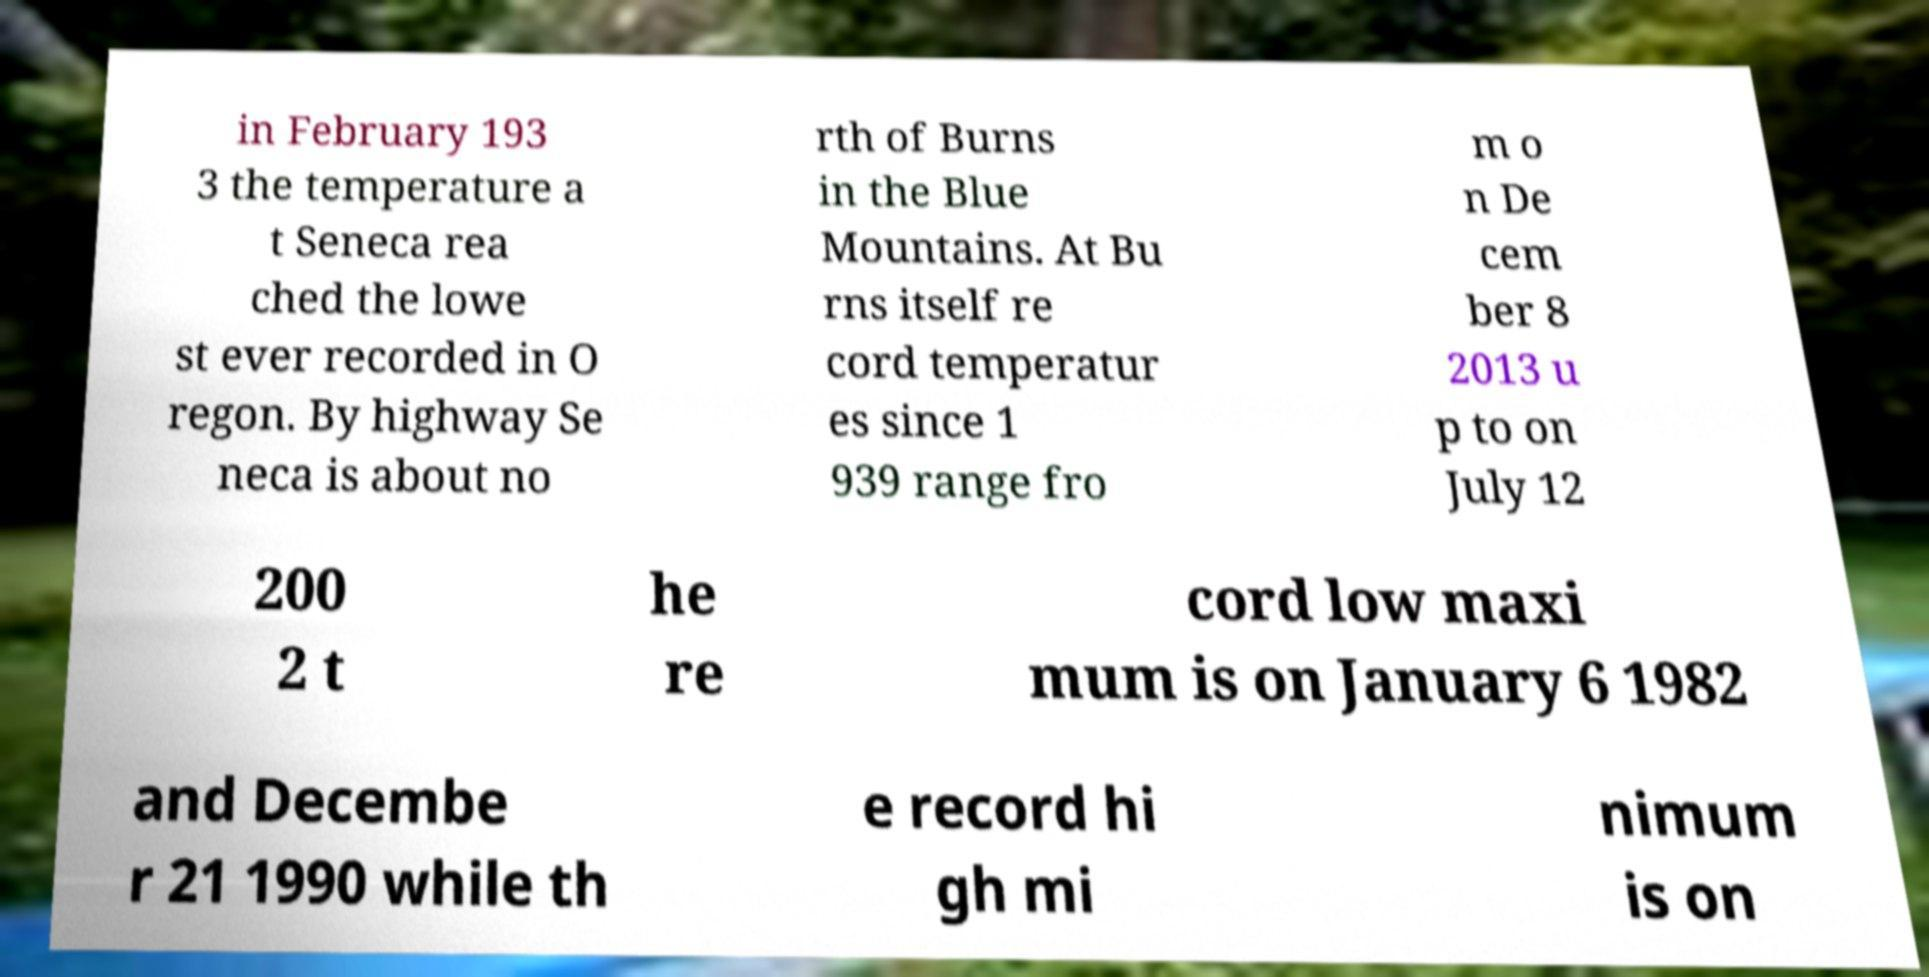I need the written content from this picture converted into text. Can you do that? in February 193 3 the temperature a t Seneca rea ched the lowe st ever recorded in O regon. By highway Se neca is about no rth of Burns in the Blue Mountains. At Bu rns itself re cord temperatur es since 1 939 range fro m o n De cem ber 8 2013 u p to on July 12 200 2 t he re cord low maxi mum is on January 6 1982 and Decembe r 21 1990 while th e record hi gh mi nimum is on 